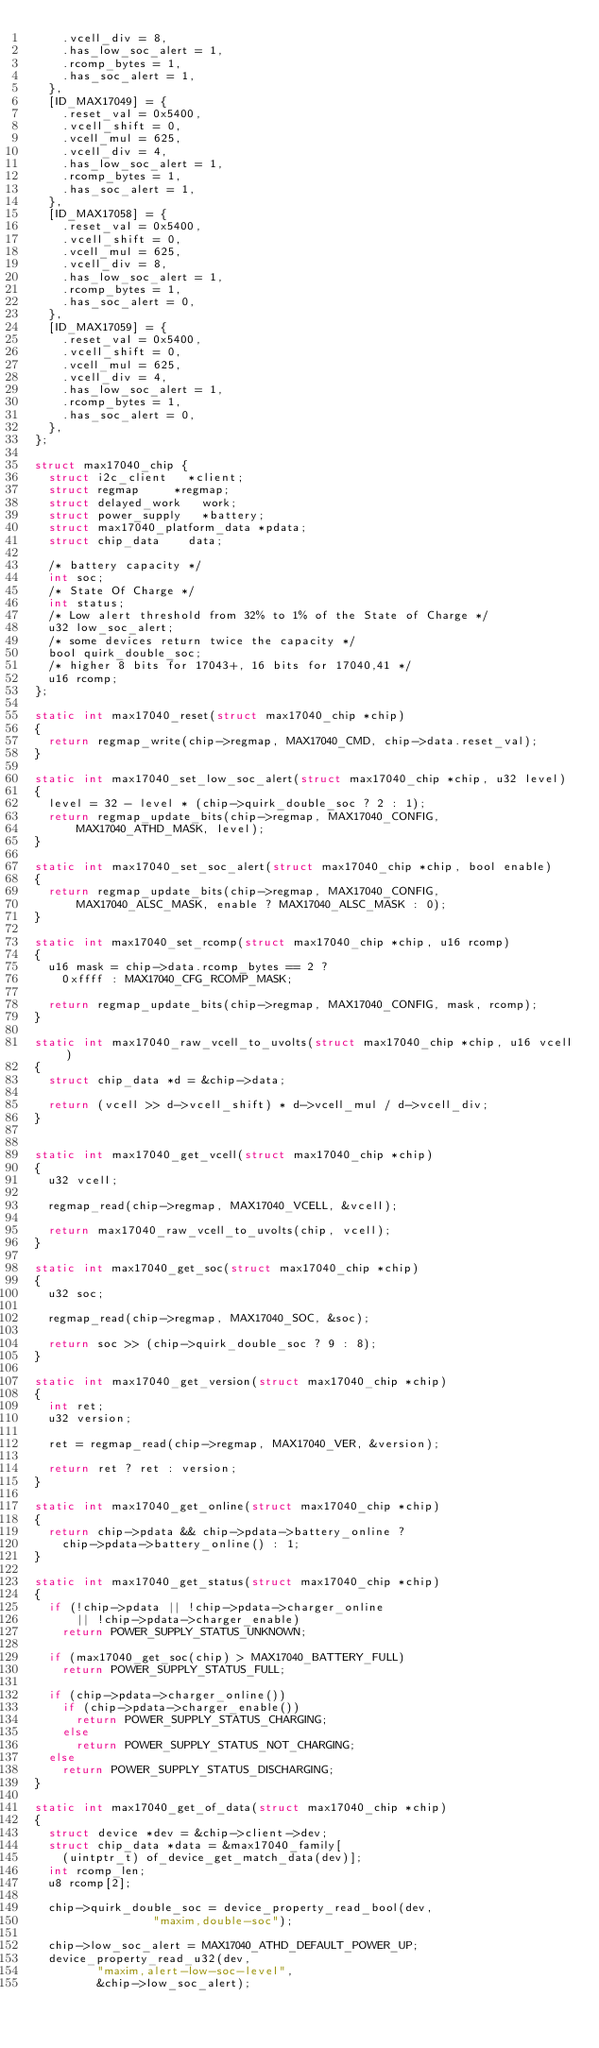Convert code to text. <code><loc_0><loc_0><loc_500><loc_500><_C_>		.vcell_div = 8,
		.has_low_soc_alert = 1,
		.rcomp_bytes = 1,
		.has_soc_alert = 1,
	},
	[ID_MAX17049] = {
		.reset_val = 0x5400,
		.vcell_shift = 0,
		.vcell_mul = 625,
		.vcell_div = 4,
		.has_low_soc_alert = 1,
		.rcomp_bytes = 1,
		.has_soc_alert = 1,
	},
	[ID_MAX17058] = {
		.reset_val = 0x5400,
		.vcell_shift = 0,
		.vcell_mul = 625,
		.vcell_div = 8,
		.has_low_soc_alert = 1,
		.rcomp_bytes = 1,
		.has_soc_alert = 0,
	},
	[ID_MAX17059] = {
		.reset_val = 0x5400,
		.vcell_shift = 0,
		.vcell_mul = 625,
		.vcell_div = 4,
		.has_low_soc_alert = 1,
		.rcomp_bytes = 1,
		.has_soc_alert = 0,
	},
};

struct max17040_chip {
	struct i2c_client		*client;
	struct regmap			*regmap;
	struct delayed_work		work;
	struct power_supply		*battery;
	struct max17040_platform_data	*pdata;
	struct chip_data		data;

	/* battery capacity */
	int soc;
	/* State Of Charge */
	int status;
	/* Low alert threshold from 32% to 1% of the State of Charge */
	u32 low_soc_alert;
	/* some devices return twice the capacity */
	bool quirk_double_soc;
	/* higher 8 bits for 17043+, 16 bits for 17040,41 */
	u16 rcomp;
};

static int max17040_reset(struct max17040_chip *chip)
{
	return regmap_write(chip->regmap, MAX17040_CMD, chip->data.reset_val);
}

static int max17040_set_low_soc_alert(struct max17040_chip *chip, u32 level)
{
	level = 32 - level * (chip->quirk_double_soc ? 2 : 1);
	return regmap_update_bits(chip->regmap, MAX17040_CONFIG,
			MAX17040_ATHD_MASK, level);
}

static int max17040_set_soc_alert(struct max17040_chip *chip, bool enable)
{
	return regmap_update_bits(chip->regmap, MAX17040_CONFIG,
			MAX17040_ALSC_MASK, enable ? MAX17040_ALSC_MASK : 0);
}

static int max17040_set_rcomp(struct max17040_chip *chip, u16 rcomp)
{
	u16 mask = chip->data.rcomp_bytes == 2 ?
		0xffff : MAX17040_CFG_RCOMP_MASK;

	return regmap_update_bits(chip->regmap, MAX17040_CONFIG, mask, rcomp);
}

static int max17040_raw_vcell_to_uvolts(struct max17040_chip *chip, u16 vcell)
{
	struct chip_data *d = &chip->data;

	return (vcell >> d->vcell_shift) * d->vcell_mul / d->vcell_div;
}


static int max17040_get_vcell(struct max17040_chip *chip)
{
	u32 vcell;

	regmap_read(chip->regmap, MAX17040_VCELL, &vcell);

	return max17040_raw_vcell_to_uvolts(chip, vcell);
}

static int max17040_get_soc(struct max17040_chip *chip)
{
	u32 soc;

	regmap_read(chip->regmap, MAX17040_SOC, &soc);

	return soc >> (chip->quirk_double_soc ? 9 : 8);
}

static int max17040_get_version(struct max17040_chip *chip)
{
	int ret;
	u32 version;

	ret = regmap_read(chip->regmap, MAX17040_VER, &version);

	return ret ? ret : version;
}

static int max17040_get_online(struct max17040_chip *chip)
{
	return chip->pdata && chip->pdata->battery_online ?
		chip->pdata->battery_online() : 1;
}

static int max17040_get_status(struct max17040_chip *chip)
{
	if (!chip->pdata || !chip->pdata->charger_online
			|| !chip->pdata->charger_enable)
		return POWER_SUPPLY_STATUS_UNKNOWN;

	if (max17040_get_soc(chip) > MAX17040_BATTERY_FULL)
		return POWER_SUPPLY_STATUS_FULL;

	if (chip->pdata->charger_online())
		if (chip->pdata->charger_enable())
			return POWER_SUPPLY_STATUS_CHARGING;
		else
			return POWER_SUPPLY_STATUS_NOT_CHARGING;
	else
		return POWER_SUPPLY_STATUS_DISCHARGING;
}

static int max17040_get_of_data(struct max17040_chip *chip)
{
	struct device *dev = &chip->client->dev;
	struct chip_data *data = &max17040_family[
		(uintptr_t) of_device_get_match_data(dev)];
	int rcomp_len;
	u8 rcomp[2];

	chip->quirk_double_soc = device_property_read_bool(dev,
							   "maxim,double-soc");

	chip->low_soc_alert = MAX17040_ATHD_DEFAULT_POWER_UP;
	device_property_read_u32(dev,
				 "maxim,alert-low-soc-level",
				 &chip->low_soc_alert);
</code> 